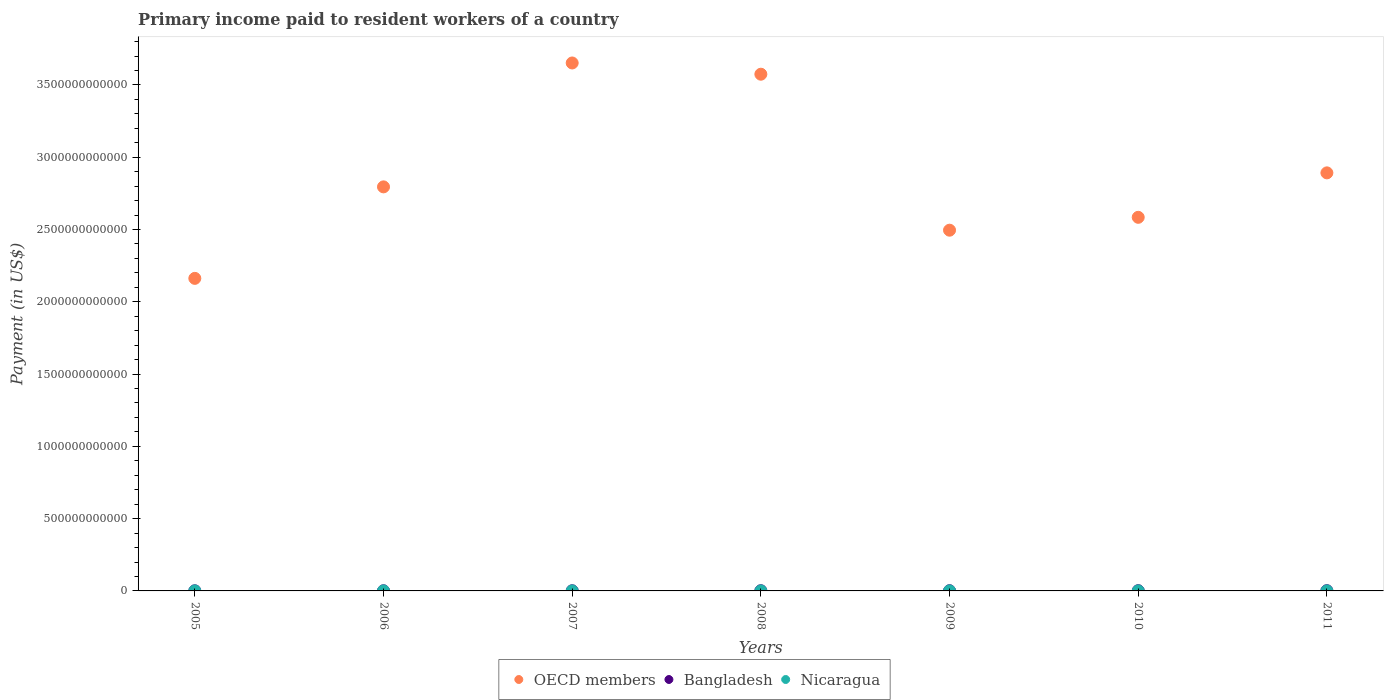How many different coloured dotlines are there?
Provide a succinct answer. 3. What is the amount paid to workers in Bangladesh in 2007?
Make the answer very short. 1.15e+09. Across all years, what is the maximum amount paid to workers in Nicaragua?
Make the answer very short. 2.71e+08. Across all years, what is the minimum amount paid to workers in Nicaragua?
Provide a short and direct response. 2.22e+08. In which year was the amount paid to workers in OECD members maximum?
Make the answer very short. 2007. In which year was the amount paid to workers in Nicaragua minimum?
Provide a succinct answer. 2005. What is the total amount paid to workers in Bangladesh in the graph?
Your response must be concise. 9.21e+09. What is the difference between the amount paid to workers in OECD members in 2008 and that in 2011?
Offer a terse response. 6.82e+11. What is the difference between the amount paid to workers in OECD members in 2009 and the amount paid to workers in Nicaragua in 2007?
Your answer should be very brief. 2.49e+12. What is the average amount paid to workers in Bangladesh per year?
Your answer should be very brief. 1.32e+09. In the year 2009, what is the difference between the amount paid to workers in Nicaragua and amount paid to workers in OECD members?
Your response must be concise. -2.49e+12. In how many years, is the amount paid to workers in Bangladesh greater than 500000000000 US$?
Offer a terse response. 0. What is the ratio of the amount paid to workers in OECD members in 2006 to that in 2010?
Make the answer very short. 1.08. What is the difference between the highest and the second highest amount paid to workers in Bangladesh?
Your answer should be compact. 5.62e+07. What is the difference between the highest and the lowest amount paid to workers in Bangladesh?
Ensure brevity in your answer.  7.60e+08. In how many years, is the amount paid to workers in Bangladesh greater than the average amount paid to workers in Bangladesh taken over all years?
Keep it short and to the point. 4. Is the sum of the amount paid to workers in Nicaragua in 2005 and 2006 greater than the maximum amount paid to workers in OECD members across all years?
Ensure brevity in your answer.  No. Is it the case that in every year, the sum of the amount paid to workers in OECD members and amount paid to workers in Nicaragua  is greater than the amount paid to workers in Bangladesh?
Provide a short and direct response. Yes. Is the amount paid to workers in OECD members strictly greater than the amount paid to workers in Bangladesh over the years?
Offer a terse response. Yes. Is the amount paid to workers in Nicaragua strictly less than the amount paid to workers in OECD members over the years?
Offer a terse response. Yes. How many dotlines are there?
Your answer should be compact. 3. How many years are there in the graph?
Your answer should be compact. 7. What is the difference between two consecutive major ticks on the Y-axis?
Offer a very short reply. 5.00e+11. Does the graph contain any zero values?
Your answer should be very brief. No. Does the graph contain grids?
Provide a short and direct response. No. How many legend labels are there?
Give a very brief answer. 3. What is the title of the graph?
Your answer should be compact. Primary income paid to resident workers of a country. What is the label or title of the X-axis?
Your response must be concise. Years. What is the label or title of the Y-axis?
Provide a succinct answer. Payment (in US$). What is the Payment (in US$) in OECD members in 2005?
Your answer should be very brief. 2.16e+12. What is the Payment (in US$) in Bangladesh in 2005?
Your answer should be compact. 9.14e+08. What is the Payment (in US$) of Nicaragua in 2005?
Make the answer very short. 2.22e+08. What is the Payment (in US$) of OECD members in 2006?
Your answer should be very brief. 2.79e+12. What is the Payment (in US$) of Bangladesh in 2006?
Your answer should be compact. 1.03e+09. What is the Payment (in US$) in Nicaragua in 2006?
Your response must be concise. 2.62e+08. What is the Payment (in US$) of OECD members in 2007?
Your response must be concise. 3.65e+12. What is the Payment (in US$) of Bangladesh in 2007?
Provide a short and direct response. 1.15e+09. What is the Payment (in US$) in Nicaragua in 2007?
Make the answer very short. 2.61e+08. What is the Payment (in US$) of OECD members in 2008?
Provide a short and direct response. 3.57e+12. What is the Payment (in US$) in Bangladesh in 2008?
Provide a succinct answer. 1.39e+09. What is the Payment (in US$) in Nicaragua in 2008?
Keep it short and to the point. 2.64e+08. What is the Payment (in US$) of OECD members in 2009?
Make the answer very short. 2.50e+12. What is the Payment (in US$) of Bangladesh in 2009?
Ensure brevity in your answer.  1.44e+09. What is the Payment (in US$) in Nicaragua in 2009?
Offer a terse response. 2.70e+08. What is the Payment (in US$) of OECD members in 2010?
Provide a succinct answer. 2.58e+12. What is the Payment (in US$) in Bangladesh in 2010?
Your answer should be compact. 1.62e+09. What is the Payment (in US$) in Nicaragua in 2010?
Make the answer very short. 2.57e+08. What is the Payment (in US$) of OECD members in 2011?
Keep it short and to the point. 2.89e+12. What is the Payment (in US$) in Bangladesh in 2011?
Provide a short and direct response. 1.67e+09. What is the Payment (in US$) in Nicaragua in 2011?
Ensure brevity in your answer.  2.71e+08. Across all years, what is the maximum Payment (in US$) in OECD members?
Your response must be concise. 3.65e+12. Across all years, what is the maximum Payment (in US$) in Bangladesh?
Keep it short and to the point. 1.67e+09. Across all years, what is the maximum Payment (in US$) of Nicaragua?
Your response must be concise. 2.71e+08. Across all years, what is the minimum Payment (in US$) in OECD members?
Offer a very short reply. 2.16e+12. Across all years, what is the minimum Payment (in US$) in Bangladesh?
Your answer should be compact. 9.14e+08. Across all years, what is the minimum Payment (in US$) in Nicaragua?
Offer a very short reply. 2.22e+08. What is the total Payment (in US$) in OECD members in the graph?
Provide a succinct answer. 2.02e+13. What is the total Payment (in US$) of Bangladesh in the graph?
Your answer should be very brief. 9.21e+09. What is the total Payment (in US$) of Nicaragua in the graph?
Make the answer very short. 1.81e+09. What is the difference between the Payment (in US$) in OECD members in 2005 and that in 2006?
Offer a very short reply. -6.33e+11. What is the difference between the Payment (in US$) of Bangladesh in 2005 and that in 2006?
Your answer should be very brief. -1.19e+08. What is the difference between the Payment (in US$) of Nicaragua in 2005 and that in 2006?
Provide a succinct answer. -3.95e+07. What is the difference between the Payment (in US$) of OECD members in 2005 and that in 2007?
Provide a succinct answer. -1.49e+12. What is the difference between the Payment (in US$) in Bangladesh in 2005 and that in 2007?
Make the answer very short. -2.33e+08. What is the difference between the Payment (in US$) in Nicaragua in 2005 and that in 2007?
Make the answer very short. -3.94e+07. What is the difference between the Payment (in US$) of OECD members in 2005 and that in 2008?
Make the answer very short. -1.41e+12. What is the difference between the Payment (in US$) of Bangladesh in 2005 and that in 2008?
Your answer should be compact. -4.72e+08. What is the difference between the Payment (in US$) of Nicaragua in 2005 and that in 2008?
Make the answer very short. -4.19e+07. What is the difference between the Payment (in US$) in OECD members in 2005 and that in 2009?
Give a very brief answer. -3.33e+11. What is the difference between the Payment (in US$) in Bangladesh in 2005 and that in 2009?
Your answer should be very brief. -5.23e+08. What is the difference between the Payment (in US$) in Nicaragua in 2005 and that in 2009?
Your answer should be compact. -4.79e+07. What is the difference between the Payment (in US$) of OECD members in 2005 and that in 2010?
Give a very brief answer. -4.22e+11. What is the difference between the Payment (in US$) in Bangladesh in 2005 and that in 2010?
Offer a terse response. -7.04e+08. What is the difference between the Payment (in US$) of Nicaragua in 2005 and that in 2010?
Provide a succinct answer. -3.46e+07. What is the difference between the Payment (in US$) in OECD members in 2005 and that in 2011?
Give a very brief answer. -7.30e+11. What is the difference between the Payment (in US$) in Bangladesh in 2005 and that in 2011?
Provide a succinct answer. -7.60e+08. What is the difference between the Payment (in US$) in Nicaragua in 2005 and that in 2011?
Offer a very short reply. -4.91e+07. What is the difference between the Payment (in US$) in OECD members in 2006 and that in 2007?
Provide a short and direct response. -8.57e+11. What is the difference between the Payment (in US$) of Bangladesh in 2006 and that in 2007?
Give a very brief answer. -1.14e+08. What is the difference between the Payment (in US$) in Nicaragua in 2006 and that in 2007?
Your answer should be very brief. 1.00e+05. What is the difference between the Payment (in US$) of OECD members in 2006 and that in 2008?
Offer a very short reply. -7.79e+11. What is the difference between the Payment (in US$) in Bangladesh in 2006 and that in 2008?
Provide a succinct answer. -3.53e+08. What is the difference between the Payment (in US$) of Nicaragua in 2006 and that in 2008?
Make the answer very short. -2.40e+06. What is the difference between the Payment (in US$) in OECD members in 2006 and that in 2009?
Offer a terse response. 3.00e+11. What is the difference between the Payment (in US$) in Bangladesh in 2006 and that in 2009?
Your answer should be compact. -4.05e+08. What is the difference between the Payment (in US$) of Nicaragua in 2006 and that in 2009?
Keep it short and to the point. -8.40e+06. What is the difference between the Payment (in US$) of OECD members in 2006 and that in 2010?
Provide a succinct answer. 2.11e+11. What is the difference between the Payment (in US$) of Bangladesh in 2006 and that in 2010?
Give a very brief answer. -5.86e+08. What is the difference between the Payment (in US$) in Nicaragua in 2006 and that in 2010?
Your answer should be compact. 4.90e+06. What is the difference between the Payment (in US$) in OECD members in 2006 and that in 2011?
Offer a terse response. -9.69e+1. What is the difference between the Payment (in US$) in Bangladesh in 2006 and that in 2011?
Provide a short and direct response. -6.42e+08. What is the difference between the Payment (in US$) of Nicaragua in 2006 and that in 2011?
Give a very brief answer. -9.60e+06. What is the difference between the Payment (in US$) in OECD members in 2007 and that in 2008?
Your answer should be very brief. 7.77e+1. What is the difference between the Payment (in US$) in Bangladesh in 2007 and that in 2008?
Make the answer very short. -2.39e+08. What is the difference between the Payment (in US$) of Nicaragua in 2007 and that in 2008?
Ensure brevity in your answer.  -2.50e+06. What is the difference between the Payment (in US$) of OECD members in 2007 and that in 2009?
Keep it short and to the point. 1.16e+12. What is the difference between the Payment (in US$) of Bangladesh in 2007 and that in 2009?
Keep it short and to the point. -2.90e+08. What is the difference between the Payment (in US$) in Nicaragua in 2007 and that in 2009?
Provide a succinct answer. -8.50e+06. What is the difference between the Payment (in US$) of OECD members in 2007 and that in 2010?
Your response must be concise. 1.07e+12. What is the difference between the Payment (in US$) in Bangladesh in 2007 and that in 2010?
Provide a short and direct response. -4.71e+08. What is the difference between the Payment (in US$) in Nicaragua in 2007 and that in 2010?
Keep it short and to the point. 4.80e+06. What is the difference between the Payment (in US$) of OECD members in 2007 and that in 2011?
Keep it short and to the point. 7.60e+11. What is the difference between the Payment (in US$) of Bangladesh in 2007 and that in 2011?
Your answer should be compact. -5.27e+08. What is the difference between the Payment (in US$) of Nicaragua in 2007 and that in 2011?
Keep it short and to the point. -9.70e+06. What is the difference between the Payment (in US$) in OECD members in 2008 and that in 2009?
Your answer should be compact. 1.08e+12. What is the difference between the Payment (in US$) in Bangladesh in 2008 and that in 2009?
Your answer should be very brief. -5.16e+07. What is the difference between the Payment (in US$) of Nicaragua in 2008 and that in 2009?
Provide a succinct answer. -6.00e+06. What is the difference between the Payment (in US$) in OECD members in 2008 and that in 2010?
Provide a succinct answer. 9.90e+11. What is the difference between the Payment (in US$) of Bangladesh in 2008 and that in 2010?
Ensure brevity in your answer.  -2.32e+08. What is the difference between the Payment (in US$) of Nicaragua in 2008 and that in 2010?
Offer a terse response. 7.30e+06. What is the difference between the Payment (in US$) of OECD members in 2008 and that in 2011?
Offer a terse response. 6.82e+11. What is the difference between the Payment (in US$) in Bangladesh in 2008 and that in 2011?
Offer a very short reply. -2.89e+08. What is the difference between the Payment (in US$) of Nicaragua in 2008 and that in 2011?
Make the answer very short. -7.20e+06. What is the difference between the Payment (in US$) of OECD members in 2009 and that in 2010?
Your response must be concise. -8.91e+1. What is the difference between the Payment (in US$) in Bangladesh in 2009 and that in 2010?
Provide a succinct answer. -1.81e+08. What is the difference between the Payment (in US$) of Nicaragua in 2009 and that in 2010?
Provide a short and direct response. 1.33e+07. What is the difference between the Payment (in US$) in OECD members in 2009 and that in 2011?
Your answer should be compact. -3.97e+11. What is the difference between the Payment (in US$) of Bangladesh in 2009 and that in 2011?
Offer a terse response. -2.37e+08. What is the difference between the Payment (in US$) of Nicaragua in 2009 and that in 2011?
Your response must be concise. -1.20e+06. What is the difference between the Payment (in US$) in OECD members in 2010 and that in 2011?
Make the answer very short. -3.07e+11. What is the difference between the Payment (in US$) of Bangladesh in 2010 and that in 2011?
Provide a short and direct response. -5.62e+07. What is the difference between the Payment (in US$) of Nicaragua in 2010 and that in 2011?
Your response must be concise. -1.45e+07. What is the difference between the Payment (in US$) of OECD members in 2005 and the Payment (in US$) of Bangladesh in 2006?
Keep it short and to the point. 2.16e+12. What is the difference between the Payment (in US$) in OECD members in 2005 and the Payment (in US$) in Nicaragua in 2006?
Make the answer very short. 2.16e+12. What is the difference between the Payment (in US$) of Bangladesh in 2005 and the Payment (in US$) of Nicaragua in 2006?
Give a very brief answer. 6.53e+08. What is the difference between the Payment (in US$) of OECD members in 2005 and the Payment (in US$) of Bangladesh in 2007?
Your answer should be very brief. 2.16e+12. What is the difference between the Payment (in US$) in OECD members in 2005 and the Payment (in US$) in Nicaragua in 2007?
Provide a succinct answer. 2.16e+12. What is the difference between the Payment (in US$) of Bangladesh in 2005 and the Payment (in US$) of Nicaragua in 2007?
Your answer should be compact. 6.53e+08. What is the difference between the Payment (in US$) of OECD members in 2005 and the Payment (in US$) of Bangladesh in 2008?
Provide a succinct answer. 2.16e+12. What is the difference between the Payment (in US$) of OECD members in 2005 and the Payment (in US$) of Nicaragua in 2008?
Provide a short and direct response. 2.16e+12. What is the difference between the Payment (in US$) in Bangladesh in 2005 and the Payment (in US$) in Nicaragua in 2008?
Offer a very short reply. 6.50e+08. What is the difference between the Payment (in US$) of OECD members in 2005 and the Payment (in US$) of Bangladesh in 2009?
Offer a terse response. 2.16e+12. What is the difference between the Payment (in US$) of OECD members in 2005 and the Payment (in US$) of Nicaragua in 2009?
Your answer should be compact. 2.16e+12. What is the difference between the Payment (in US$) in Bangladesh in 2005 and the Payment (in US$) in Nicaragua in 2009?
Your response must be concise. 6.44e+08. What is the difference between the Payment (in US$) in OECD members in 2005 and the Payment (in US$) in Bangladesh in 2010?
Make the answer very short. 2.16e+12. What is the difference between the Payment (in US$) of OECD members in 2005 and the Payment (in US$) of Nicaragua in 2010?
Make the answer very short. 2.16e+12. What is the difference between the Payment (in US$) in Bangladesh in 2005 and the Payment (in US$) in Nicaragua in 2010?
Your answer should be compact. 6.58e+08. What is the difference between the Payment (in US$) of OECD members in 2005 and the Payment (in US$) of Bangladesh in 2011?
Your answer should be very brief. 2.16e+12. What is the difference between the Payment (in US$) of OECD members in 2005 and the Payment (in US$) of Nicaragua in 2011?
Your response must be concise. 2.16e+12. What is the difference between the Payment (in US$) in Bangladesh in 2005 and the Payment (in US$) in Nicaragua in 2011?
Provide a succinct answer. 6.43e+08. What is the difference between the Payment (in US$) in OECD members in 2006 and the Payment (in US$) in Bangladesh in 2007?
Offer a terse response. 2.79e+12. What is the difference between the Payment (in US$) in OECD members in 2006 and the Payment (in US$) in Nicaragua in 2007?
Give a very brief answer. 2.79e+12. What is the difference between the Payment (in US$) of Bangladesh in 2006 and the Payment (in US$) of Nicaragua in 2007?
Offer a very short reply. 7.71e+08. What is the difference between the Payment (in US$) in OECD members in 2006 and the Payment (in US$) in Bangladesh in 2008?
Ensure brevity in your answer.  2.79e+12. What is the difference between the Payment (in US$) of OECD members in 2006 and the Payment (in US$) of Nicaragua in 2008?
Your response must be concise. 2.79e+12. What is the difference between the Payment (in US$) in Bangladesh in 2006 and the Payment (in US$) in Nicaragua in 2008?
Provide a short and direct response. 7.69e+08. What is the difference between the Payment (in US$) in OECD members in 2006 and the Payment (in US$) in Bangladesh in 2009?
Give a very brief answer. 2.79e+12. What is the difference between the Payment (in US$) in OECD members in 2006 and the Payment (in US$) in Nicaragua in 2009?
Ensure brevity in your answer.  2.79e+12. What is the difference between the Payment (in US$) of Bangladesh in 2006 and the Payment (in US$) of Nicaragua in 2009?
Ensure brevity in your answer.  7.63e+08. What is the difference between the Payment (in US$) of OECD members in 2006 and the Payment (in US$) of Bangladesh in 2010?
Offer a terse response. 2.79e+12. What is the difference between the Payment (in US$) of OECD members in 2006 and the Payment (in US$) of Nicaragua in 2010?
Offer a terse response. 2.79e+12. What is the difference between the Payment (in US$) in Bangladesh in 2006 and the Payment (in US$) in Nicaragua in 2010?
Keep it short and to the point. 7.76e+08. What is the difference between the Payment (in US$) in OECD members in 2006 and the Payment (in US$) in Bangladesh in 2011?
Keep it short and to the point. 2.79e+12. What is the difference between the Payment (in US$) in OECD members in 2006 and the Payment (in US$) in Nicaragua in 2011?
Give a very brief answer. 2.79e+12. What is the difference between the Payment (in US$) in Bangladesh in 2006 and the Payment (in US$) in Nicaragua in 2011?
Provide a short and direct response. 7.62e+08. What is the difference between the Payment (in US$) in OECD members in 2007 and the Payment (in US$) in Bangladesh in 2008?
Provide a succinct answer. 3.65e+12. What is the difference between the Payment (in US$) of OECD members in 2007 and the Payment (in US$) of Nicaragua in 2008?
Your answer should be very brief. 3.65e+12. What is the difference between the Payment (in US$) in Bangladesh in 2007 and the Payment (in US$) in Nicaragua in 2008?
Your answer should be very brief. 8.83e+08. What is the difference between the Payment (in US$) of OECD members in 2007 and the Payment (in US$) of Bangladesh in 2009?
Make the answer very short. 3.65e+12. What is the difference between the Payment (in US$) in OECD members in 2007 and the Payment (in US$) in Nicaragua in 2009?
Make the answer very short. 3.65e+12. What is the difference between the Payment (in US$) of Bangladesh in 2007 and the Payment (in US$) of Nicaragua in 2009?
Your answer should be compact. 8.77e+08. What is the difference between the Payment (in US$) of OECD members in 2007 and the Payment (in US$) of Bangladesh in 2010?
Make the answer very short. 3.65e+12. What is the difference between the Payment (in US$) of OECD members in 2007 and the Payment (in US$) of Nicaragua in 2010?
Keep it short and to the point. 3.65e+12. What is the difference between the Payment (in US$) of Bangladesh in 2007 and the Payment (in US$) of Nicaragua in 2010?
Provide a short and direct response. 8.91e+08. What is the difference between the Payment (in US$) in OECD members in 2007 and the Payment (in US$) in Bangladesh in 2011?
Your response must be concise. 3.65e+12. What is the difference between the Payment (in US$) in OECD members in 2007 and the Payment (in US$) in Nicaragua in 2011?
Offer a very short reply. 3.65e+12. What is the difference between the Payment (in US$) in Bangladesh in 2007 and the Payment (in US$) in Nicaragua in 2011?
Your answer should be very brief. 8.76e+08. What is the difference between the Payment (in US$) in OECD members in 2008 and the Payment (in US$) in Bangladesh in 2009?
Provide a short and direct response. 3.57e+12. What is the difference between the Payment (in US$) in OECD members in 2008 and the Payment (in US$) in Nicaragua in 2009?
Your response must be concise. 3.57e+12. What is the difference between the Payment (in US$) in Bangladesh in 2008 and the Payment (in US$) in Nicaragua in 2009?
Keep it short and to the point. 1.12e+09. What is the difference between the Payment (in US$) of OECD members in 2008 and the Payment (in US$) of Bangladesh in 2010?
Provide a succinct answer. 3.57e+12. What is the difference between the Payment (in US$) in OECD members in 2008 and the Payment (in US$) in Nicaragua in 2010?
Offer a terse response. 3.57e+12. What is the difference between the Payment (in US$) in Bangladesh in 2008 and the Payment (in US$) in Nicaragua in 2010?
Offer a terse response. 1.13e+09. What is the difference between the Payment (in US$) in OECD members in 2008 and the Payment (in US$) in Bangladesh in 2011?
Provide a short and direct response. 3.57e+12. What is the difference between the Payment (in US$) of OECD members in 2008 and the Payment (in US$) of Nicaragua in 2011?
Keep it short and to the point. 3.57e+12. What is the difference between the Payment (in US$) in Bangladesh in 2008 and the Payment (in US$) in Nicaragua in 2011?
Give a very brief answer. 1.11e+09. What is the difference between the Payment (in US$) in OECD members in 2009 and the Payment (in US$) in Bangladesh in 2010?
Provide a succinct answer. 2.49e+12. What is the difference between the Payment (in US$) in OECD members in 2009 and the Payment (in US$) in Nicaragua in 2010?
Offer a very short reply. 2.49e+12. What is the difference between the Payment (in US$) in Bangladesh in 2009 and the Payment (in US$) in Nicaragua in 2010?
Your answer should be very brief. 1.18e+09. What is the difference between the Payment (in US$) of OECD members in 2009 and the Payment (in US$) of Bangladesh in 2011?
Offer a terse response. 2.49e+12. What is the difference between the Payment (in US$) in OECD members in 2009 and the Payment (in US$) in Nicaragua in 2011?
Give a very brief answer. 2.49e+12. What is the difference between the Payment (in US$) of Bangladesh in 2009 and the Payment (in US$) of Nicaragua in 2011?
Provide a short and direct response. 1.17e+09. What is the difference between the Payment (in US$) in OECD members in 2010 and the Payment (in US$) in Bangladesh in 2011?
Offer a terse response. 2.58e+12. What is the difference between the Payment (in US$) of OECD members in 2010 and the Payment (in US$) of Nicaragua in 2011?
Your response must be concise. 2.58e+12. What is the difference between the Payment (in US$) of Bangladesh in 2010 and the Payment (in US$) of Nicaragua in 2011?
Provide a short and direct response. 1.35e+09. What is the average Payment (in US$) of OECD members per year?
Make the answer very short. 2.88e+12. What is the average Payment (in US$) in Bangladesh per year?
Your answer should be compact. 1.32e+09. What is the average Payment (in US$) in Nicaragua per year?
Your answer should be compact. 2.58e+08. In the year 2005, what is the difference between the Payment (in US$) of OECD members and Payment (in US$) of Bangladesh?
Your answer should be very brief. 2.16e+12. In the year 2005, what is the difference between the Payment (in US$) of OECD members and Payment (in US$) of Nicaragua?
Provide a short and direct response. 2.16e+12. In the year 2005, what is the difference between the Payment (in US$) in Bangladesh and Payment (in US$) in Nicaragua?
Offer a terse response. 6.92e+08. In the year 2006, what is the difference between the Payment (in US$) in OECD members and Payment (in US$) in Bangladesh?
Offer a very short reply. 2.79e+12. In the year 2006, what is the difference between the Payment (in US$) of OECD members and Payment (in US$) of Nicaragua?
Give a very brief answer. 2.79e+12. In the year 2006, what is the difference between the Payment (in US$) in Bangladesh and Payment (in US$) in Nicaragua?
Give a very brief answer. 7.71e+08. In the year 2007, what is the difference between the Payment (in US$) in OECD members and Payment (in US$) in Bangladesh?
Offer a terse response. 3.65e+12. In the year 2007, what is the difference between the Payment (in US$) in OECD members and Payment (in US$) in Nicaragua?
Make the answer very short. 3.65e+12. In the year 2007, what is the difference between the Payment (in US$) of Bangladesh and Payment (in US$) of Nicaragua?
Provide a short and direct response. 8.86e+08. In the year 2008, what is the difference between the Payment (in US$) in OECD members and Payment (in US$) in Bangladesh?
Your response must be concise. 3.57e+12. In the year 2008, what is the difference between the Payment (in US$) of OECD members and Payment (in US$) of Nicaragua?
Your answer should be compact. 3.57e+12. In the year 2008, what is the difference between the Payment (in US$) of Bangladesh and Payment (in US$) of Nicaragua?
Ensure brevity in your answer.  1.12e+09. In the year 2009, what is the difference between the Payment (in US$) of OECD members and Payment (in US$) of Bangladesh?
Your answer should be compact. 2.49e+12. In the year 2009, what is the difference between the Payment (in US$) in OECD members and Payment (in US$) in Nicaragua?
Ensure brevity in your answer.  2.49e+12. In the year 2009, what is the difference between the Payment (in US$) in Bangladesh and Payment (in US$) in Nicaragua?
Give a very brief answer. 1.17e+09. In the year 2010, what is the difference between the Payment (in US$) of OECD members and Payment (in US$) of Bangladesh?
Provide a succinct answer. 2.58e+12. In the year 2010, what is the difference between the Payment (in US$) of OECD members and Payment (in US$) of Nicaragua?
Offer a terse response. 2.58e+12. In the year 2010, what is the difference between the Payment (in US$) of Bangladesh and Payment (in US$) of Nicaragua?
Make the answer very short. 1.36e+09. In the year 2011, what is the difference between the Payment (in US$) in OECD members and Payment (in US$) in Bangladesh?
Offer a very short reply. 2.89e+12. In the year 2011, what is the difference between the Payment (in US$) of OECD members and Payment (in US$) of Nicaragua?
Your answer should be very brief. 2.89e+12. In the year 2011, what is the difference between the Payment (in US$) in Bangladesh and Payment (in US$) in Nicaragua?
Your answer should be compact. 1.40e+09. What is the ratio of the Payment (in US$) in OECD members in 2005 to that in 2006?
Offer a terse response. 0.77. What is the ratio of the Payment (in US$) of Bangladesh in 2005 to that in 2006?
Your answer should be very brief. 0.89. What is the ratio of the Payment (in US$) in Nicaragua in 2005 to that in 2006?
Offer a very short reply. 0.85. What is the ratio of the Payment (in US$) of OECD members in 2005 to that in 2007?
Your answer should be compact. 0.59. What is the ratio of the Payment (in US$) of Bangladesh in 2005 to that in 2007?
Your answer should be compact. 0.8. What is the ratio of the Payment (in US$) of Nicaragua in 2005 to that in 2007?
Your answer should be compact. 0.85. What is the ratio of the Payment (in US$) of OECD members in 2005 to that in 2008?
Provide a short and direct response. 0.6. What is the ratio of the Payment (in US$) of Bangladesh in 2005 to that in 2008?
Your answer should be compact. 0.66. What is the ratio of the Payment (in US$) of Nicaragua in 2005 to that in 2008?
Provide a short and direct response. 0.84. What is the ratio of the Payment (in US$) in OECD members in 2005 to that in 2009?
Offer a very short reply. 0.87. What is the ratio of the Payment (in US$) of Bangladesh in 2005 to that in 2009?
Offer a terse response. 0.64. What is the ratio of the Payment (in US$) of Nicaragua in 2005 to that in 2009?
Keep it short and to the point. 0.82. What is the ratio of the Payment (in US$) in OECD members in 2005 to that in 2010?
Ensure brevity in your answer.  0.84. What is the ratio of the Payment (in US$) in Bangladesh in 2005 to that in 2010?
Your answer should be compact. 0.56. What is the ratio of the Payment (in US$) of Nicaragua in 2005 to that in 2010?
Offer a terse response. 0.87. What is the ratio of the Payment (in US$) in OECD members in 2005 to that in 2011?
Provide a succinct answer. 0.75. What is the ratio of the Payment (in US$) in Bangladesh in 2005 to that in 2011?
Your answer should be compact. 0.55. What is the ratio of the Payment (in US$) of Nicaragua in 2005 to that in 2011?
Ensure brevity in your answer.  0.82. What is the ratio of the Payment (in US$) of OECD members in 2006 to that in 2007?
Provide a succinct answer. 0.77. What is the ratio of the Payment (in US$) of Bangladesh in 2006 to that in 2007?
Give a very brief answer. 0.9. What is the ratio of the Payment (in US$) of Nicaragua in 2006 to that in 2007?
Provide a succinct answer. 1. What is the ratio of the Payment (in US$) of OECD members in 2006 to that in 2008?
Make the answer very short. 0.78. What is the ratio of the Payment (in US$) of Bangladesh in 2006 to that in 2008?
Ensure brevity in your answer.  0.75. What is the ratio of the Payment (in US$) of Nicaragua in 2006 to that in 2008?
Ensure brevity in your answer.  0.99. What is the ratio of the Payment (in US$) of OECD members in 2006 to that in 2009?
Make the answer very short. 1.12. What is the ratio of the Payment (in US$) in Bangladesh in 2006 to that in 2009?
Keep it short and to the point. 0.72. What is the ratio of the Payment (in US$) of Nicaragua in 2006 to that in 2009?
Your response must be concise. 0.97. What is the ratio of the Payment (in US$) in OECD members in 2006 to that in 2010?
Your answer should be very brief. 1.08. What is the ratio of the Payment (in US$) of Bangladesh in 2006 to that in 2010?
Keep it short and to the point. 0.64. What is the ratio of the Payment (in US$) of Nicaragua in 2006 to that in 2010?
Keep it short and to the point. 1.02. What is the ratio of the Payment (in US$) in OECD members in 2006 to that in 2011?
Give a very brief answer. 0.97. What is the ratio of the Payment (in US$) of Bangladesh in 2006 to that in 2011?
Your answer should be compact. 0.62. What is the ratio of the Payment (in US$) in Nicaragua in 2006 to that in 2011?
Ensure brevity in your answer.  0.96. What is the ratio of the Payment (in US$) of OECD members in 2007 to that in 2008?
Your answer should be compact. 1.02. What is the ratio of the Payment (in US$) of Bangladesh in 2007 to that in 2008?
Your answer should be compact. 0.83. What is the ratio of the Payment (in US$) of OECD members in 2007 to that in 2009?
Keep it short and to the point. 1.46. What is the ratio of the Payment (in US$) in Bangladesh in 2007 to that in 2009?
Offer a terse response. 0.8. What is the ratio of the Payment (in US$) in Nicaragua in 2007 to that in 2009?
Make the answer very short. 0.97. What is the ratio of the Payment (in US$) of OECD members in 2007 to that in 2010?
Ensure brevity in your answer.  1.41. What is the ratio of the Payment (in US$) in Bangladesh in 2007 to that in 2010?
Offer a terse response. 0.71. What is the ratio of the Payment (in US$) of Nicaragua in 2007 to that in 2010?
Provide a short and direct response. 1.02. What is the ratio of the Payment (in US$) of OECD members in 2007 to that in 2011?
Ensure brevity in your answer.  1.26. What is the ratio of the Payment (in US$) of Bangladesh in 2007 to that in 2011?
Ensure brevity in your answer.  0.69. What is the ratio of the Payment (in US$) in Nicaragua in 2007 to that in 2011?
Offer a very short reply. 0.96. What is the ratio of the Payment (in US$) of OECD members in 2008 to that in 2009?
Offer a terse response. 1.43. What is the ratio of the Payment (in US$) in Bangladesh in 2008 to that in 2009?
Your answer should be very brief. 0.96. What is the ratio of the Payment (in US$) in Nicaragua in 2008 to that in 2009?
Offer a very short reply. 0.98. What is the ratio of the Payment (in US$) of OECD members in 2008 to that in 2010?
Make the answer very short. 1.38. What is the ratio of the Payment (in US$) of Bangladesh in 2008 to that in 2010?
Offer a very short reply. 0.86. What is the ratio of the Payment (in US$) in Nicaragua in 2008 to that in 2010?
Your response must be concise. 1.03. What is the ratio of the Payment (in US$) of OECD members in 2008 to that in 2011?
Offer a very short reply. 1.24. What is the ratio of the Payment (in US$) in Bangladesh in 2008 to that in 2011?
Offer a terse response. 0.83. What is the ratio of the Payment (in US$) of Nicaragua in 2008 to that in 2011?
Make the answer very short. 0.97. What is the ratio of the Payment (in US$) of OECD members in 2009 to that in 2010?
Provide a short and direct response. 0.97. What is the ratio of the Payment (in US$) of Bangladesh in 2009 to that in 2010?
Offer a terse response. 0.89. What is the ratio of the Payment (in US$) of Nicaragua in 2009 to that in 2010?
Provide a short and direct response. 1.05. What is the ratio of the Payment (in US$) of OECD members in 2009 to that in 2011?
Provide a succinct answer. 0.86. What is the ratio of the Payment (in US$) in Bangladesh in 2009 to that in 2011?
Give a very brief answer. 0.86. What is the ratio of the Payment (in US$) in OECD members in 2010 to that in 2011?
Offer a very short reply. 0.89. What is the ratio of the Payment (in US$) of Bangladesh in 2010 to that in 2011?
Your response must be concise. 0.97. What is the ratio of the Payment (in US$) of Nicaragua in 2010 to that in 2011?
Keep it short and to the point. 0.95. What is the difference between the highest and the second highest Payment (in US$) of OECD members?
Your response must be concise. 7.77e+1. What is the difference between the highest and the second highest Payment (in US$) of Bangladesh?
Your answer should be very brief. 5.62e+07. What is the difference between the highest and the second highest Payment (in US$) of Nicaragua?
Your answer should be very brief. 1.20e+06. What is the difference between the highest and the lowest Payment (in US$) of OECD members?
Your response must be concise. 1.49e+12. What is the difference between the highest and the lowest Payment (in US$) of Bangladesh?
Provide a succinct answer. 7.60e+08. What is the difference between the highest and the lowest Payment (in US$) of Nicaragua?
Make the answer very short. 4.91e+07. 